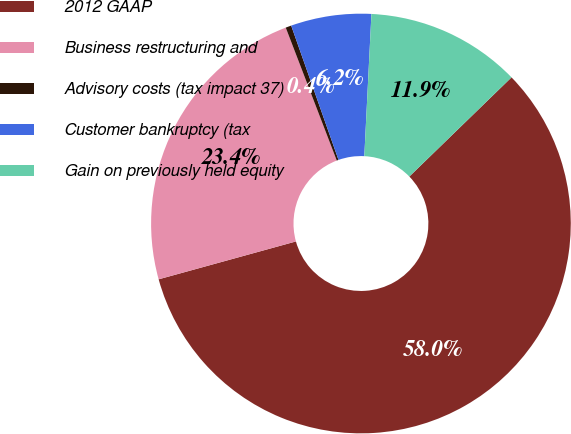<chart> <loc_0><loc_0><loc_500><loc_500><pie_chart><fcel>2012 GAAP<fcel>Business restructuring and<fcel>Advisory costs (tax impact 37)<fcel>Customer bankruptcy (tax<fcel>Gain on previously held equity<nl><fcel>57.98%<fcel>23.45%<fcel>0.44%<fcel>6.19%<fcel>11.94%<nl></chart> 